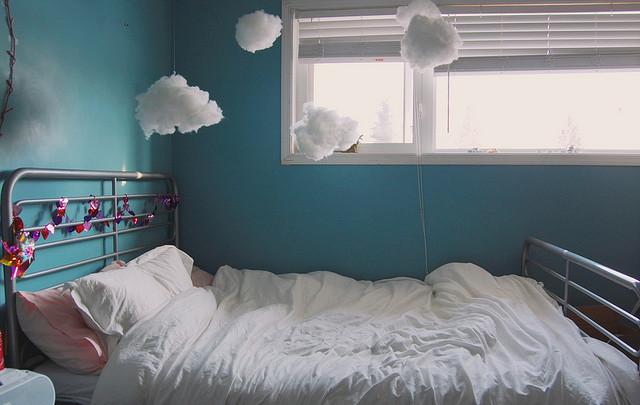What room is this?
Concise answer only. Bedroom. What color is the comforter?
Short answer required. White. What color is the wall?
Quick response, please. Blue. What color are the walls?
Write a very short answer. Blue. 